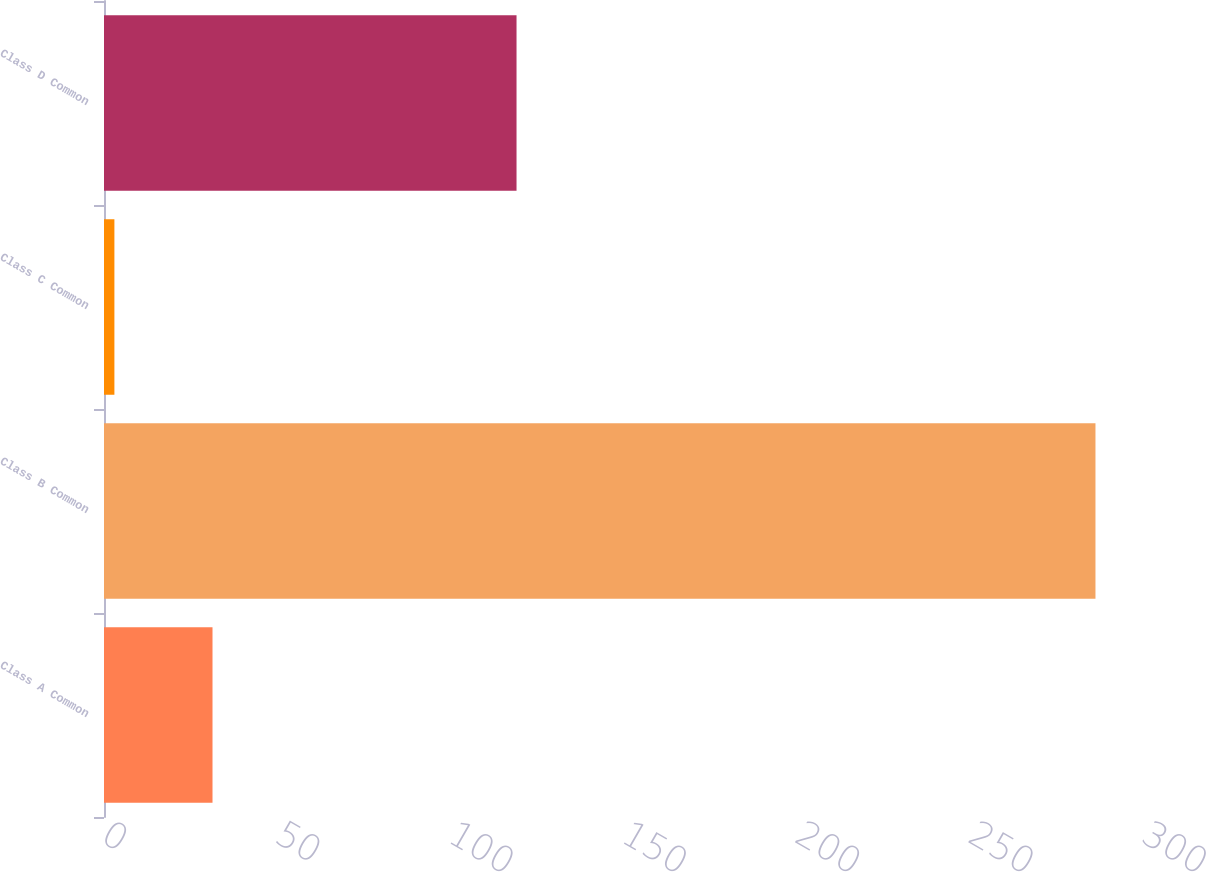Convert chart. <chart><loc_0><loc_0><loc_500><loc_500><bar_chart><fcel>Class A Common<fcel>Class B Common<fcel>Class C Common<fcel>Class D Common<nl><fcel>31.3<fcel>286<fcel>3<fcel>119<nl></chart> 